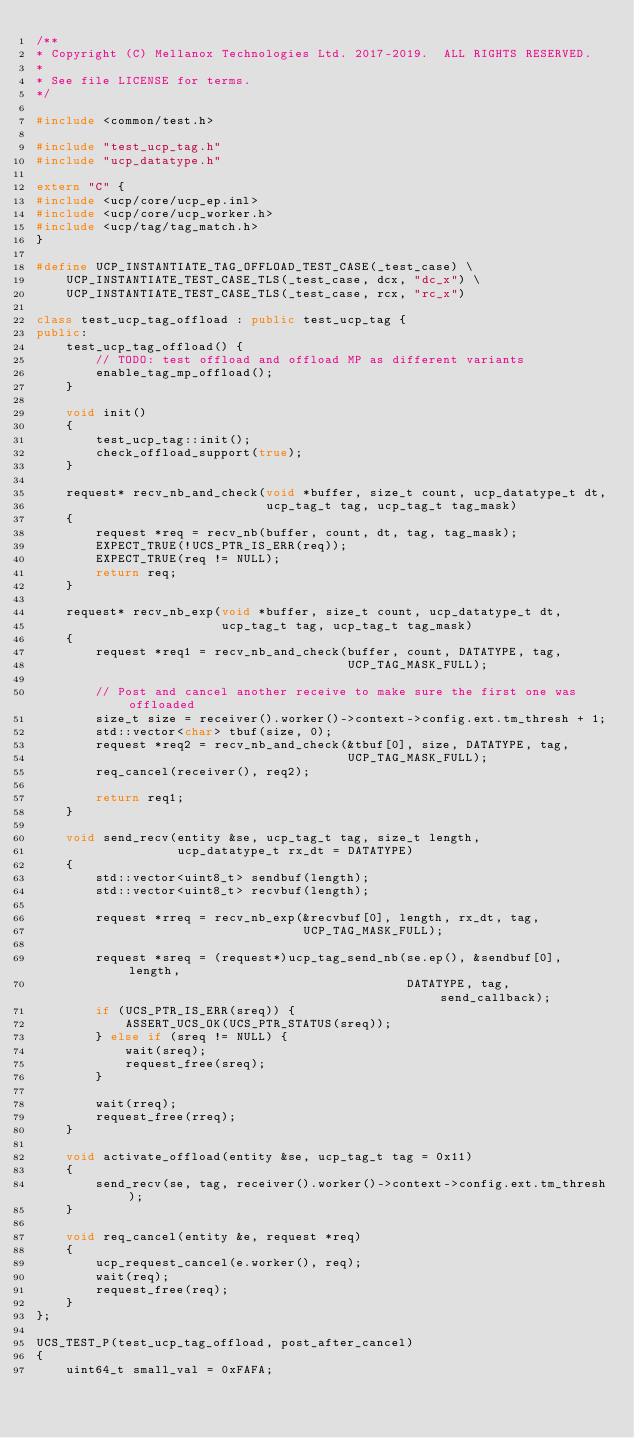<code> <loc_0><loc_0><loc_500><loc_500><_C++_>/**
* Copyright (C) Mellanox Technologies Ltd. 2017-2019.  ALL RIGHTS RESERVED.
*
* See file LICENSE for terms.
*/

#include <common/test.h>

#include "test_ucp_tag.h"
#include "ucp_datatype.h"

extern "C" {
#include <ucp/core/ucp_ep.inl>
#include <ucp/core/ucp_worker.h>
#include <ucp/tag/tag_match.h>
}

#define UCP_INSTANTIATE_TAG_OFFLOAD_TEST_CASE(_test_case) \
    UCP_INSTANTIATE_TEST_CASE_TLS(_test_case, dcx, "dc_x") \
    UCP_INSTANTIATE_TEST_CASE_TLS(_test_case, rcx, "rc_x")

class test_ucp_tag_offload : public test_ucp_tag {
public:
    test_ucp_tag_offload() {
        // TODO: test offload and offload MP as different variants
        enable_tag_mp_offload();
    }

    void init()
    {
        test_ucp_tag::init();
        check_offload_support(true);
    }

    request* recv_nb_and_check(void *buffer, size_t count, ucp_datatype_t dt,
                               ucp_tag_t tag, ucp_tag_t tag_mask)
    {
        request *req = recv_nb(buffer, count, dt, tag, tag_mask);
        EXPECT_TRUE(!UCS_PTR_IS_ERR(req));
        EXPECT_TRUE(req != NULL);
        return req;
    }

    request* recv_nb_exp(void *buffer, size_t count, ucp_datatype_t dt,
                         ucp_tag_t tag, ucp_tag_t tag_mask)
    {
        request *req1 = recv_nb_and_check(buffer, count, DATATYPE, tag,
                                          UCP_TAG_MASK_FULL);

        // Post and cancel another receive to make sure the first one was offloaded
        size_t size = receiver().worker()->context->config.ext.tm_thresh + 1;
        std::vector<char> tbuf(size, 0);
        request *req2 = recv_nb_and_check(&tbuf[0], size, DATATYPE, tag,
                                          UCP_TAG_MASK_FULL);
        req_cancel(receiver(), req2);

        return req1;
    }

    void send_recv(entity &se, ucp_tag_t tag, size_t length,
                   ucp_datatype_t rx_dt = DATATYPE)
    {
        std::vector<uint8_t> sendbuf(length);
        std::vector<uint8_t> recvbuf(length);

        request *rreq = recv_nb_exp(&recvbuf[0], length, rx_dt, tag,
                                    UCP_TAG_MASK_FULL);

        request *sreq = (request*)ucp_tag_send_nb(se.ep(), &sendbuf[0], length,
                                                  DATATYPE, tag, send_callback);
        if (UCS_PTR_IS_ERR(sreq)) {
            ASSERT_UCS_OK(UCS_PTR_STATUS(sreq));
        } else if (sreq != NULL) {
            wait(sreq);
            request_free(sreq);
        }

        wait(rreq);
        request_free(rreq);
    }

    void activate_offload(entity &se, ucp_tag_t tag = 0x11)
    {
        send_recv(se, tag, receiver().worker()->context->config.ext.tm_thresh);
    }

    void req_cancel(entity &e, request *req)
    {
        ucp_request_cancel(e.worker(), req);
        wait(req);
        request_free(req);
    }
};

UCS_TEST_P(test_ucp_tag_offload, post_after_cancel)
{
    uint64_t small_val = 0xFAFA;</code> 